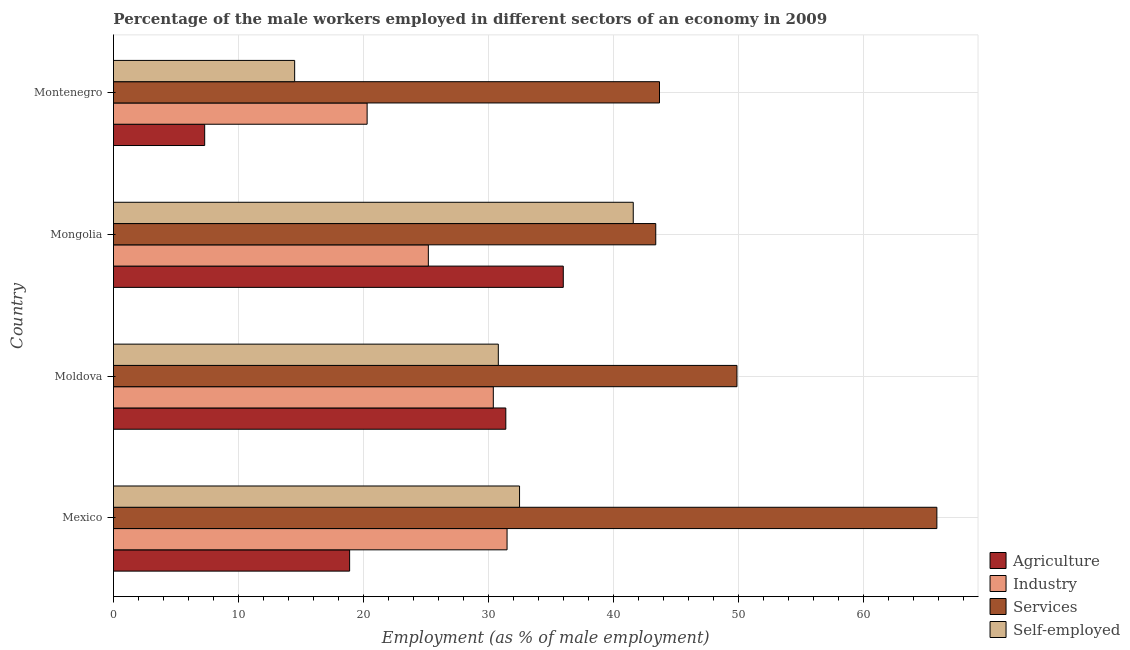How many groups of bars are there?
Provide a succinct answer. 4. Are the number of bars per tick equal to the number of legend labels?
Provide a succinct answer. Yes. Are the number of bars on each tick of the Y-axis equal?
Your answer should be compact. Yes. How many bars are there on the 4th tick from the top?
Your answer should be very brief. 4. How many bars are there on the 1st tick from the bottom?
Your response must be concise. 4. What is the label of the 3rd group of bars from the top?
Your answer should be very brief. Moldova. What is the percentage of male workers in industry in Mexico?
Your response must be concise. 31.5. Across all countries, what is the maximum percentage of male workers in industry?
Make the answer very short. 31.5. Across all countries, what is the minimum percentage of male workers in industry?
Give a very brief answer. 20.3. In which country was the percentage of male workers in industry minimum?
Your response must be concise. Montenegro. What is the total percentage of male workers in agriculture in the graph?
Provide a short and direct response. 93.6. What is the difference between the percentage of male workers in industry in Mexico and the percentage of male workers in agriculture in Montenegro?
Your response must be concise. 24.2. What is the average percentage of male workers in services per country?
Make the answer very short. 50.73. What is the difference between the percentage of male workers in industry and percentage of self employed male workers in Mongolia?
Provide a short and direct response. -16.4. In how many countries, is the percentage of male workers in industry greater than 18 %?
Keep it short and to the point. 4. What is the ratio of the percentage of male workers in industry in Mexico to that in Moldova?
Give a very brief answer. 1.04. Is the difference between the percentage of male workers in industry in Mexico and Moldova greater than the difference between the percentage of male workers in services in Mexico and Moldova?
Ensure brevity in your answer.  No. What is the difference between the highest and the lowest percentage of self employed male workers?
Provide a short and direct response. 27.1. In how many countries, is the percentage of self employed male workers greater than the average percentage of self employed male workers taken over all countries?
Your answer should be very brief. 3. Is the sum of the percentage of self employed male workers in Moldova and Montenegro greater than the maximum percentage of male workers in services across all countries?
Give a very brief answer. No. What does the 4th bar from the top in Montenegro represents?
Provide a succinct answer. Agriculture. What does the 2nd bar from the bottom in Moldova represents?
Provide a short and direct response. Industry. Is it the case that in every country, the sum of the percentage of male workers in agriculture and percentage of male workers in industry is greater than the percentage of male workers in services?
Keep it short and to the point. No. How many countries are there in the graph?
Provide a short and direct response. 4. What is the difference between two consecutive major ticks on the X-axis?
Provide a succinct answer. 10. Does the graph contain grids?
Keep it short and to the point. Yes. What is the title of the graph?
Offer a terse response. Percentage of the male workers employed in different sectors of an economy in 2009. What is the label or title of the X-axis?
Ensure brevity in your answer.  Employment (as % of male employment). What is the Employment (as % of male employment) in Agriculture in Mexico?
Provide a short and direct response. 18.9. What is the Employment (as % of male employment) of Industry in Mexico?
Offer a very short reply. 31.5. What is the Employment (as % of male employment) in Services in Mexico?
Offer a very short reply. 65.9. What is the Employment (as % of male employment) of Self-employed in Mexico?
Your answer should be compact. 32.5. What is the Employment (as % of male employment) in Agriculture in Moldova?
Keep it short and to the point. 31.4. What is the Employment (as % of male employment) of Industry in Moldova?
Your answer should be very brief. 30.4. What is the Employment (as % of male employment) of Services in Moldova?
Give a very brief answer. 49.9. What is the Employment (as % of male employment) of Self-employed in Moldova?
Your response must be concise. 30.8. What is the Employment (as % of male employment) of Agriculture in Mongolia?
Make the answer very short. 36. What is the Employment (as % of male employment) in Industry in Mongolia?
Give a very brief answer. 25.2. What is the Employment (as % of male employment) of Services in Mongolia?
Ensure brevity in your answer.  43.4. What is the Employment (as % of male employment) of Self-employed in Mongolia?
Offer a very short reply. 41.6. What is the Employment (as % of male employment) in Agriculture in Montenegro?
Your answer should be very brief. 7.3. What is the Employment (as % of male employment) in Industry in Montenegro?
Your answer should be compact. 20.3. What is the Employment (as % of male employment) of Services in Montenegro?
Your answer should be very brief. 43.7. Across all countries, what is the maximum Employment (as % of male employment) of Industry?
Give a very brief answer. 31.5. Across all countries, what is the maximum Employment (as % of male employment) of Services?
Your answer should be very brief. 65.9. Across all countries, what is the maximum Employment (as % of male employment) of Self-employed?
Offer a very short reply. 41.6. Across all countries, what is the minimum Employment (as % of male employment) of Agriculture?
Provide a short and direct response. 7.3. Across all countries, what is the minimum Employment (as % of male employment) in Industry?
Make the answer very short. 20.3. Across all countries, what is the minimum Employment (as % of male employment) in Services?
Your answer should be very brief. 43.4. Across all countries, what is the minimum Employment (as % of male employment) in Self-employed?
Provide a succinct answer. 14.5. What is the total Employment (as % of male employment) in Agriculture in the graph?
Give a very brief answer. 93.6. What is the total Employment (as % of male employment) of Industry in the graph?
Your response must be concise. 107.4. What is the total Employment (as % of male employment) of Services in the graph?
Your response must be concise. 202.9. What is the total Employment (as % of male employment) in Self-employed in the graph?
Provide a succinct answer. 119.4. What is the difference between the Employment (as % of male employment) in Services in Mexico and that in Moldova?
Offer a very short reply. 16. What is the difference between the Employment (as % of male employment) of Self-employed in Mexico and that in Moldova?
Your answer should be compact. 1.7. What is the difference between the Employment (as % of male employment) of Agriculture in Mexico and that in Mongolia?
Provide a short and direct response. -17.1. What is the difference between the Employment (as % of male employment) in Industry in Mexico and that in Mongolia?
Keep it short and to the point. 6.3. What is the difference between the Employment (as % of male employment) of Services in Mexico and that in Mongolia?
Your answer should be compact. 22.5. What is the difference between the Employment (as % of male employment) in Self-employed in Mexico and that in Mongolia?
Give a very brief answer. -9.1. What is the difference between the Employment (as % of male employment) of Services in Mexico and that in Montenegro?
Provide a succinct answer. 22.2. What is the difference between the Employment (as % of male employment) in Self-employed in Mexico and that in Montenegro?
Give a very brief answer. 18. What is the difference between the Employment (as % of male employment) of Agriculture in Moldova and that in Mongolia?
Offer a very short reply. -4.6. What is the difference between the Employment (as % of male employment) in Industry in Moldova and that in Mongolia?
Ensure brevity in your answer.  5.2. What is the difference between the Employment (as % of male employment) of Agriculture in Moldova and that in Montenegro?
Give a very brief answer. 24.1. What is the difference between the Employment (as % of male employment) in Industry in Moldova and that in Montenegro?
Make the answer very short. 10.1. What is the difference between the Employment (as % of male employment) of Agriculture in Mongolia and that in Montenegro?
Ensure brevity in your answer.  28.7. What is the difference between the Employment (as % of male employment) of Industry in Mongolia and that in Montenegro?
Offer a terse response. 4.9. What is the difference between the Employment (as % of male employment) of Self-employed in Mongolia and that in Montenegro?
Offer a terse response. 27.1. What is the difference between the Employment (as % of male employment) in Agriculture in Mexico and the Employment (as % of male employment) in Services in Moldova?
Your answer should be compact. -31. What is the difference between the Employment (as % of male employment) of Agriculture in Mexico and the Employment (as % of male employment) of Self-employed in Moldova?
Your response must be concise. -11.9. What is the difference between the Employment (as % of male employment) in Industry in Mexico and the Employment (as % of male employment) in Services in Moldova?
Keep it short and to the point. -18.4. What is the difference between the Employment (as % of male employment) in Industry in Mexico and the Employment (as % of male employment) in Self-employed in Moldova?
Give a very brief answer. 0.7. What is the difference between the Employment (as % of male employment) of Services in Mexico and the Employment (as % of male employment) of Self-employed in Moldova?
Offer a very short reply. 35.1. What is the difference between the Employment (as % of male employment) in Agriculture in Mexico and the Employment (as % of male employment) in Services in Mongolia?
Offer a terse response. -24.5. What is the difference between the Employment (as % of male employment) of Agriculture in Mexico and the Employment (as % of male employment) of Self-employed in Mongolia?
Ensure brevity in your answer.  -22.7. What is the difference between the Employment (as % of male employment) in Industry in Mexico and the Employment (as % of male employment) in Services in Mongolia?
Offer a very short reply. -11.9. What is the difference between the Employment (as % of male employment) in Industry in Mexico and the Employment (as % of male employment) in Self-employed in Mongolia?
Your response must be concise. -10.1. What is the difference between the Employment (as % of male employment) in Services in Mexico and the Employment (as % of male employment) in Self-employed in Mongolia?
Provide a succinct answer. 24.3. What is the difference between the Employment (as % of male employment) in Agriculture in Mexico and the Employment (as % of male employment) in Services in Montenegro?
Your answer should be very brief. -24.8. What is the difference between the Employment (as % of male employment) in Industry in Mexico and the Employment (as % of male employment) in Services in Montenegro?
Give a very brief answer. -12.2. What is the difference between the Employment (as % of male employment) in Services in Mexico and the Employment (as % of male employment) in Self-employed in Montenegro?
Your answer should be compact. 51.4. What is the difference between the Employment (as % of male employment) of Agriculture in Moldova and the Employment (as % of male employment) of Industry in Mongolia?
Make the answer very short. 6.2. What is the difference between the Employment (as % of male employment) of Agriculture in Moldova and the Employment (as % of male employment) of Self-employed in Mongolia?
Offer a very short reply. -10.2. What is the difference between the Employment (as % of male employment) of Industry in Moldova and the Employment (as % of male employment) of Services in Mongolia?
Give a very brief answer. -13. What is the difference between the Employment (as % of male employment) of Services in Moldova and the Employment (as % of male employment) of Self-employed in Mongolia?
Provide a short and direct response. 8.3. What is the difference between the Employment (as % of male employment) of Agriculture in Moldova and the Employment (as % of male employment) of Self-employed in Montenegro?
Ensure brevity in your answer.  16.9. What is the difference between the Employment (as % of male employment) of Industry in Moldova and the Employment (as % of male employment) of Self-employed in Montenegro?
Offer a very short reply. 15.9. What is the difference between the Employment (as % of male employment) of Services in Moldova and the Employment (as % of male employment) of Self-employed in Montenegro?
Your response must be concise. 35.4. What is the difference between the Employment (as % of male employment) in Agriculture in Mongolia and the Employment (as % of male employment) in Industry in Montenegro?
Give a very brief answer. 15.7. What is the difference between the Employment (as % of male employment) in Agriculture in Mongolia and the Employment (as % of male employment) in Services in Montenegro?
Your answer should be very brief. -7.7. What is the difference between the Employment (as % of male employment) of Agriculture in Mongolia and the Employment (as % of male employment) of Self-employed in Montenegro?
Provide a succinct answer. 21.5. What is the difference between the Employment (as % of male employment) in Industry in Mongolia and the Employment (as % of male employment) in Services in Montenegro?
Ensure brevity in your answer.  -18.5. What is the difference between the Employment (as % of male employment) of Services in Mongolia and the Employment (as % of male employment) of Self-employed in Montenegro?
Give a very brief answer. 28.9. What is the average Employment (as % of male employment) of Agriculture per country?
Your response must be concise. 23.4. What is the average Employment (as % of male employment) of Industry per country?
Make the answer very short. 26.85. What is the average Employment (as % of male employment) in Services per country?
Ensure brevity in your answer.  50.73. What is the average Employment (as % of male employment) of Self-employed per country?
Your answer should be very brief. 29.85. What is the difference between the Employment (as % of male employment) in Agriculture and Employment (as % of male employment) in Services in Mexico?
Ensure brevity in your answer.  -47. What is the difference between the Employment (as % of male employment) of Industry and Employment (as % of male employment) of Services in Mexico?
Your answer should be very brief. -34.4. What is the difference between the Employment (as % of male employment) in Industry and Employment (as % of male employment) in Self-employed in Mexico?
Give a very brief answer. -1. What is the difference between the Employment (as % of male employment) of Services and Employment (as % of male employment) of Self-employed in Mexico?
Offer a terse response. 33.4. What is the difference between the Employment (as % of male employment) of Agriculture and Employment (as % of male employment) of Services in Moldova?
Offer a very short reply. -18.5. What is the difference between the Employment (as % of male employment) in Industry and Employment (as % of male employment) in Services in Moldova?
Give a very brief answer. -19.5. What is the difference between the Employment (as % of male employment) of Agriculture and Employment (as % of male employment) of Industry in Mongolia?
Your response must be concise. 10.8. What is the difference between the Employment (as % of male employment) of Agriculture and Employment (as % of male employment) of Self-employed in Mongolia?
Provide a short and direct response. -5.6. What is the difference between the Employment (as % of male employment) in Industry and Employment (as % of male employment) in Services in Mongolia?
Offer a very short reply. -18.2. What is the difference between the Employment (as % of male employment) of Industry and Employment (as % of male employment) of Self-employed in Mongolia?
Provide a succinct answer. -16.4. What is the difference between the Employment (as % of male employment) in Services and Employment (as % of male employment) in Self-employed in Mongolia?
Offer a very short reply. 1.8. What is the difference between the Employment (as % of male employment) in Agriculture and Employment (as % of male employment) in Services in Montenegro?
Offer a terse response. -36.4. What is the difference between the Employment (as % of male employment) in Industry and Employment (as % of male employment) in Services in Montenegro?
Provide a short and direct response. -23.4. What is the difference between the Employment (as % of male employment) of Services and Employment (as % of male employment) of Self-employed in Montenegro?
Offer a very short reply. 29.2. What is the ratio of the Employment (as % of male employment) in Agriculture in Mexico to that in Moldova?
Ensure brevity in your answer.  0.6. What is the ratio of the Employment (as % of male employment) in Industry in Mexico to that in Moldova?
Your answer should be very brief. 1.04. What is the ratio of the Employment (as % of male employment) in Services in Mexico to that in Moldova?
Your answer should be very brief. 1.32. What is the ratio of the Employment (as % of male employment) of Self-employed in Mexico to that in Moldova?
Your answer should be very brief. 1.06. What is the ratio of the Employment (as % of male employment) in Agriculture in Mexico to that in Mongolia?
Offer a terse response. 0.53. What is the ratio of the Employment (as % of male employment) of Industry in Mexico to that in Mongolia?
Ensure brevity in your answer.  1.25. What is the ratio of the Employment (as % of male employment) in Services in Mexico to that in Mongolia?
Keep it short and to the point. 1.52. What is the ratio of the Employment (as % of male employment) of Self-employed in Mexico to that in Mongolia?
Give a very brief answer. 0.78. What is the ratio of the Employment (as % of male employment) in Agriculture in Mexico to that in Montenegro?
Keep it short and to the point. 2.59. What is the ratio of the Employment (as % of male employment) of Industry in Mexico to that in Montenegro?
Your answer should be very brief. 1.55. What is the ratio of the Employment (as % of male employment) in Services in Mexico to that in Montenegro?
Your response must be concise. 1.51. What is the ratio of the Employment (as % of male employment) of Self-employed in Mexico to that in Montenegro?
Make the answer very short. 2.24. What is the ratio of the Employment (as % of male employment) of Agriculture in Moldova to that in Mongolia?
Give a very brief answer. 0.87. What is the ratio of the Employment (as % of male employment) of Industry in Moldova to that in Mongolia?
Provide a short and direct response. 1.21. What is the ratio of the Employment (as % of male employment) of Services in Moldova to that in Mongolia?
Your response must be concise. 1.15. What is the ratio of the Employment (as % of male employment) in Self-employed in Moldova to that in Mongolia?
Provide a succinct answer. 0.74. What is the ratio of the Employment (as % of male employment) in Agriculture in Moldova to that in Montenegro?
Give a very brief answer. 4.3. What is the ratio of the Employment (as % of male employment) of Industry in Moldova to that in Montenegro?
Provide a succinct answer. 1.5. What is the ratio of the Employment (as % of male employment) of Services in Moldova to that in Montenegro?
Provide a short and direct response. 1.14. What is the ratio of the Employment (as % of male employment) in Self-employed in Moldova to that in Montenegro?
Provide a succinct answer. 2.12. What is the ratio of the Employment (as % of male employment) in Agriculture in Mongolia to that in Montenegro?
Make the answer very short. 4.93. What is the ratio of the Employment (as % of male employment) of Industry in Mongolia to that in Montenegro?
Offer a terse response. 1.24. What is the ratio of the Employment (as % of male employment) of Services in Mongolia to that in Montenegro?
Make the answer very short. 0.99. What is the ratio of the Employment (as % of male employment) of Self-employed in Mongolia to that in Montenegro?
Make the answer very short. 2.87. What is the difference between the highest and the second highest Employment (as % of male employment) in Agriculture?
Ensure brevity in your answer.  4.6. What is the difference between the highest and the second highest Employment (as % of male employment) of Services?
Make the answer very short. 16. What is the difference between the highest and the second highest Employment (as % of male employment) in Self-employed?
Your response must be concise. 9.1. What is the difference between the highest and the lowest Employment (as % of male employment) in Agriculture?
Provide a short and direct response. 28.7. What is the difference between the highest and the lowest Employment (as % of male employment) in Self-employed?
Provide a succinct answer. 27.1. 